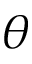<formula> <loc_0><loc_0><loc_500><loc_500>\theta</formula> 